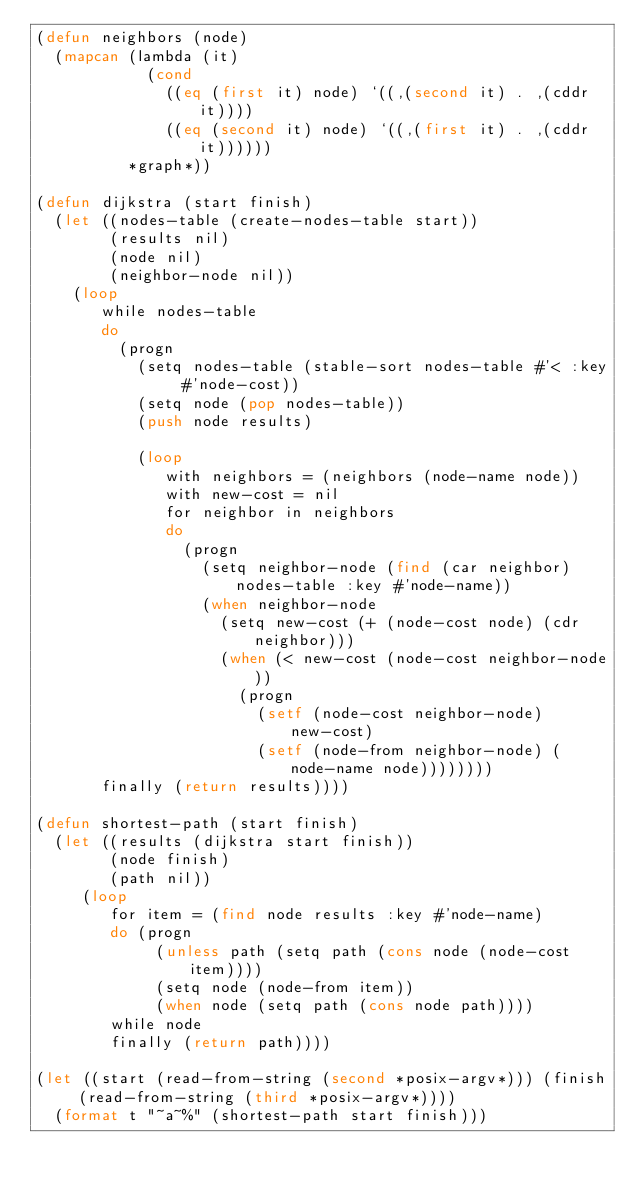Convert code to text. <code><loc_0><loc_0><loc_500><loc_500><_Lisp_>(defun neighbors (node)
  (mapcan (lambda (it)
            (cond
              ((eq (first it) node) `((,(second it) . ,(cddr it))))
              ((eq (second it) node) `((,(first it) . ,(cddr it))))))
          *graph*))

(defun dijkstra (start finish)
  (let ((nodes-table (create-nodes-table start))
        (results nil)
        (node nil)
        (neighbor-node nil))
    (loop
       while nodes-table
       do
         (progn
           (setq nodes-table (stable-sort nodes-table #'< :key #'node-cost))
           (setq node (pop nodes-table))
           (push node results)

           (loop
              with neighbors = (neighbors (node-name node))
              with new-cost = nil
              for neighbor in neighbors
              do
                (progn
                  (setq neighbor-node (find (car neighbor) nodes-table :key #'node-name))
                  (when neighbor-node
                    (setq new-cost (+ (node-cost node) (cdr neighbor)))
                    (when (< new-cost (node-cost neighbor-node))
                      (progn
                        (setf (node-cost neighbor-node) new-cost)
                        (setf (node-from neighbor-node) (node-name node))))))))
       finally (return results))))

(defun shortest-path (start finish)
  (let ((results (dijkstra start finish))
        (node finish)
        (path nil))
     (loop
        for item = (find node results :key #'node-name)
        do (progn
             (unless path (setq path (cons node (node-cost item))))
             (setq node (node-from item))
             (when node (setq path (cons node path))))
        while node
        finally (return path))))

(let ((start (read-from-string (second *posix-argv*))) (finish (read-from-string (third *posix-argv*))))
  (format t "~a~%" (shortest-path start finish)))

</code> 